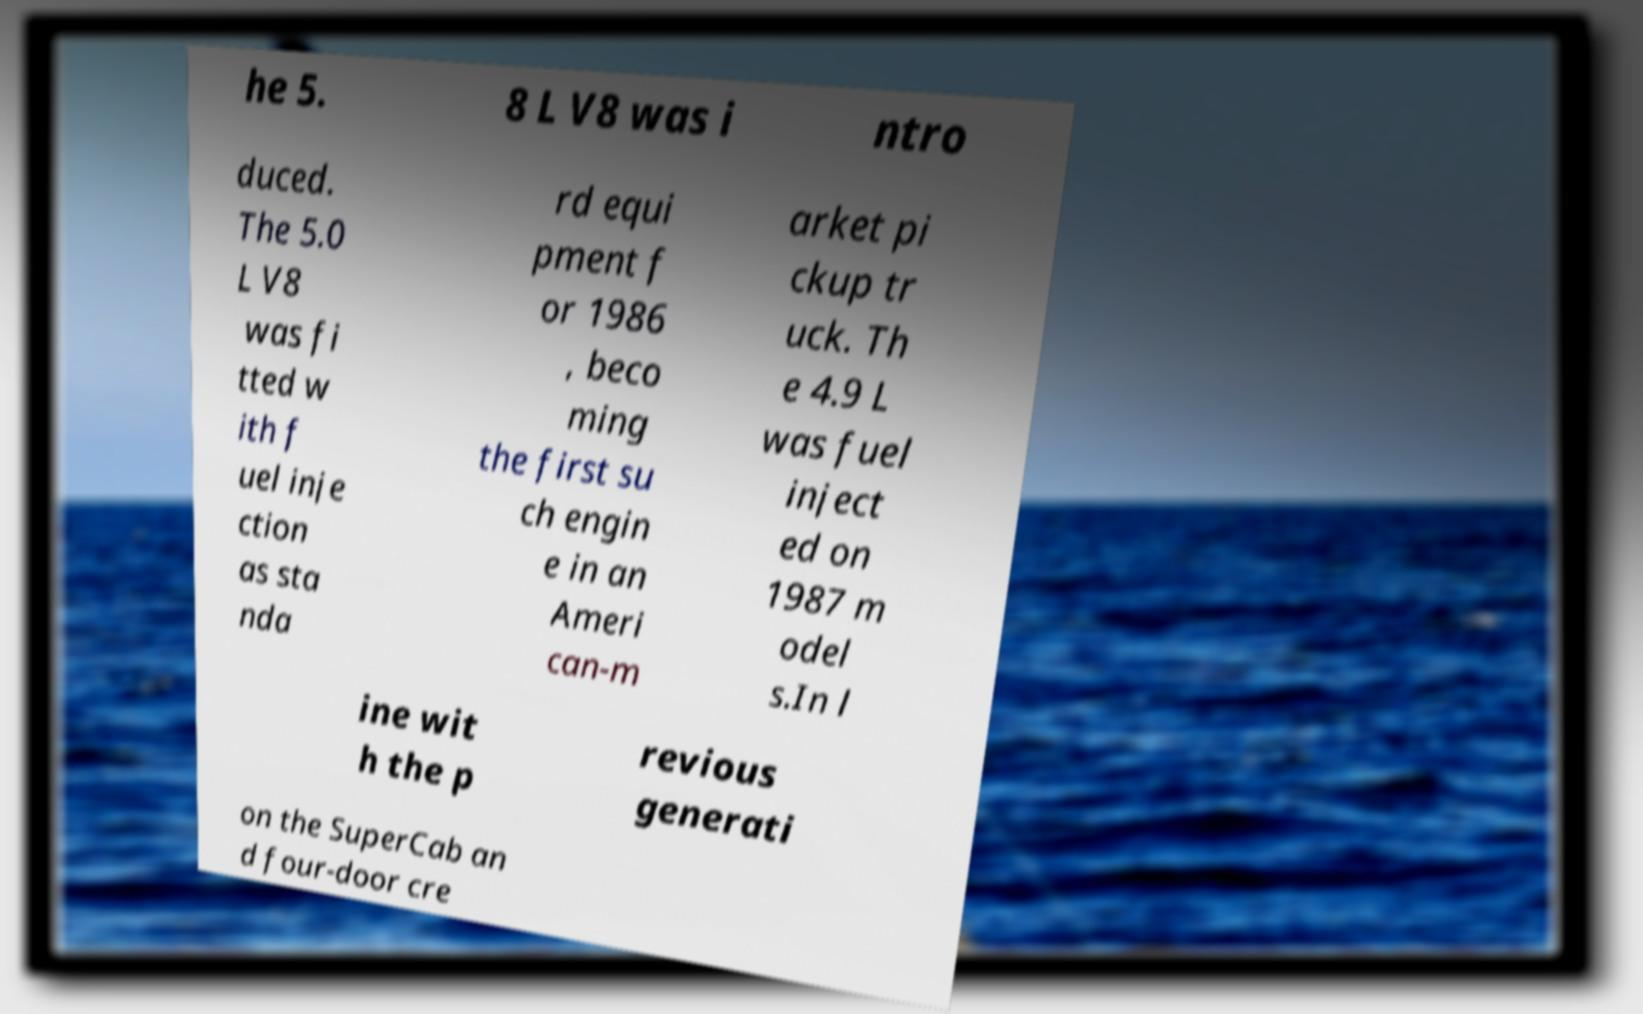Please identify and transcribe the text found in this image. he 5. 8 L V8 was i ntro duced. The 5.0 L V8 was fi tted w ith f uel inje ction as sta nda rd equi pment f or 1986 , beco ming the first su ch engin e in an Ameri can-m arket pi ckup tr uck. Th e 4.9 L was fuel inject ed on 1987 m odel s.In l ine wit h the p revious generati on the SuperCab an d four-door cre 